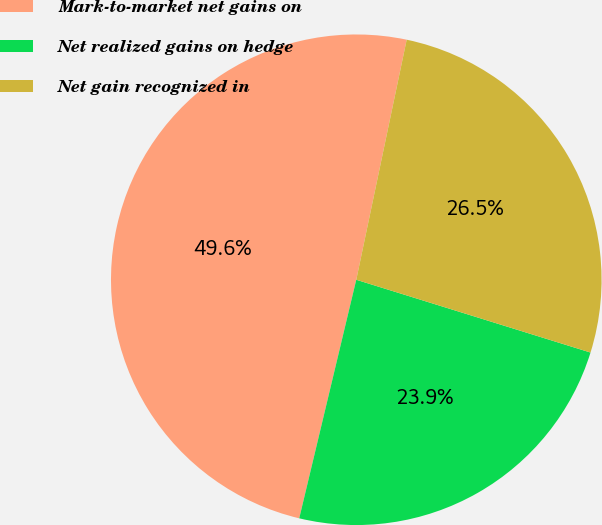Convert chart to OTSL. <chart><loc_0><loc_0><loc_500><loc_500><pie_chart><fcel>Mark-to-market net gains on<fcel>Net realized gains on hedge<fcel>Net gain recognized in<nl><fcel>49.56%<fcel>23.94%<fcel>26.5%<nl></chart> 